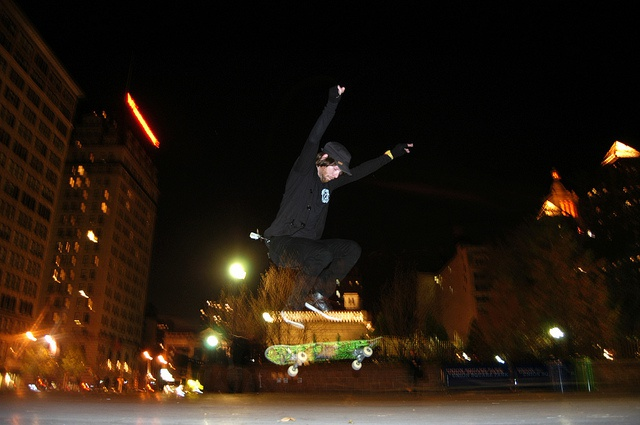Describe the objects in this image and their specific colors. I can see people in black, maroon, gray, and white tones, skateboard in black, olive, and gray tones, and bench in black and purple tones in this image. 